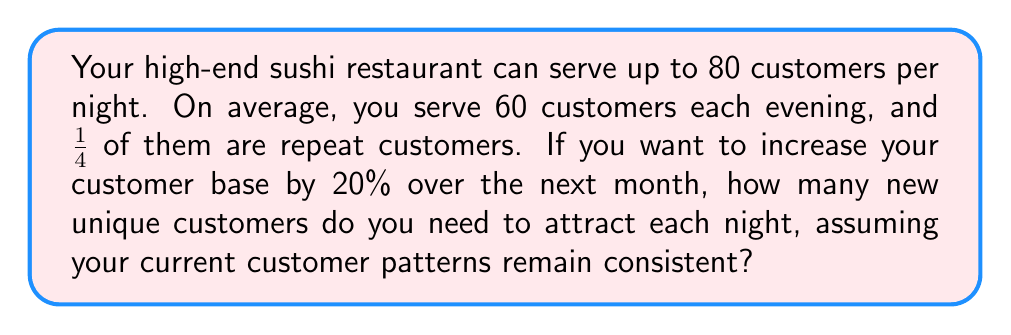Solve this math problem. Let's break this down step-by-step:

1) First, let's calculate the number of new customers you currently serve each night:
   - Total customers per night = 60
   - Repeat customers = $\frac{1}{4}$ of 60 = $60 \times \frac{1}{4} = 15$
   - New customers = Total - Repeat = $60 - 15 = 45$

2) Now, let's calculate your current unique customer base per night:
   - Unique customers = New customers + Repeat customers
   - Unique customers = $45 + 15 = 60$

3) You want to increase this by 20%:
   - Increase = $60 \times 20\% = 60 \times \frac{20}{100} = 12$
   - New target for unique customers = $60 + 12 = 72$

4) To reach this target, you need to keep your repeat customers (15) and increase your new customers:
   - New customers needed = Target unique customers - Repeat customers
   - New customers needed = $72 - 15 = 57$

5) Finally, calculate how many additional new customers you need each night:
   - Additional new customers = New customers needed - Current new customers
   - Additional new customers = $57 - 45 = 12$

Therefore, you need to attract 12 additional new unique customers each night to achieve your 20% growth target.
Answer: 12 new unique customers per night 